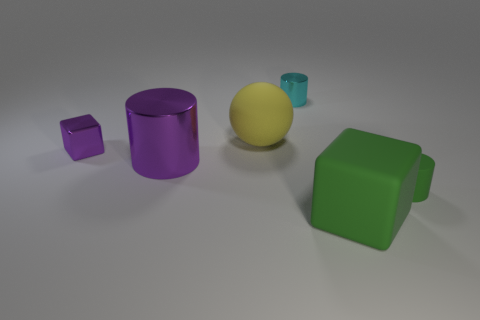There is a small object that is the same color as the large metallic cylinder; what shape is it?
Your answer should be compact. Cube. What is the color of the other shiny cylinder that is the same size as the green cylinder?
Your answer should be compact. Cyan. There is a big rubber sphere that is to the right of the metallic thing to the left of the purple metallic cylinder; what is its color?
Make the answer very short. Yellow. Does the rubber thing that is behind the tiny matte cylinder have the same color as the matte block?
Ensure brevity in your answer.  No. What shape is the green thing that is to the right of the green matte object that is in front of the small thing on the right side of the small cyan metal cylinder?
Make the answer very short. Cylinder. There is a tiny cylinder that is right of the small cyan cylinder; what number of large cylinders are behind it?
Offer a terse response. 1. Do the small cube and the large green object have the same material?
Provide a succinct answer. No. What number of cylinders are to the right of the green object in front of the small cylinder that is in front of the tiny metal cylinder?
Your answer should be compact. 1. There is a tiny object that is on the right side of the cyan thing; what color is it?
Offer a very short reply. Green. There is a big matte object that is on the left side of the cube that is in front of the tiny green cylinder; what is its shape?
Keep it short and to the point. Sphere. 